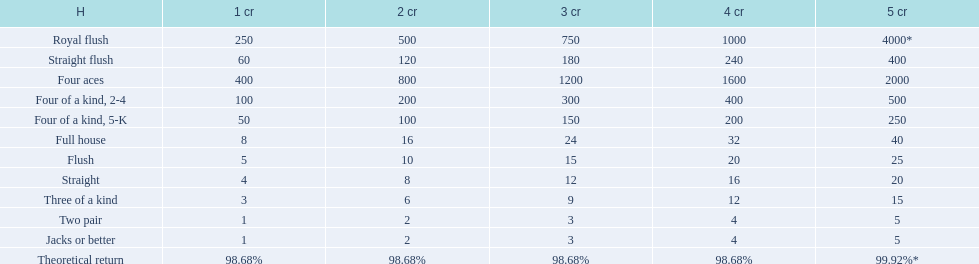After winning on four credits with a full house, what is your payout? 32. 